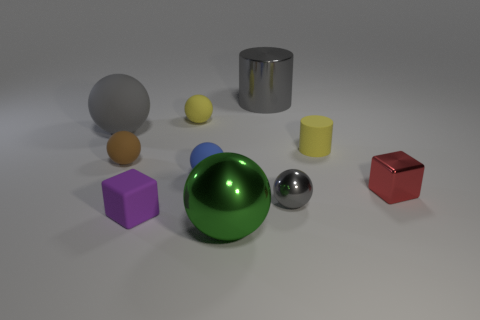Subtract all tiny gray shiny balls. How many balls are left? 5 Subtract all green spheres. How many spheres are left? 5 Subtract 1 spheres. How many spheres are left? 5 Subtract all cyan balls. Subtract all green cylinders. How many balls are left? 6 Subtract all cylinders. How many objects are left? 8 Subtract 0 blue cubes. How many objects are left? 10 Subtract all big cyan blocks. Subtract all tiny metallic things. How many objects are left? 8 Add 6 small brown matte spheres. How many small brown matte spheres are left? 7 Add 8 blue rubber objects. How many blue rubber objects exist? 9 